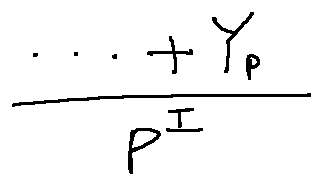<formula> <loc_0><loc_0><loc_500><loc_500>\frac { \cdots + Y _ { P } } { p ^ { I } }</formula> 